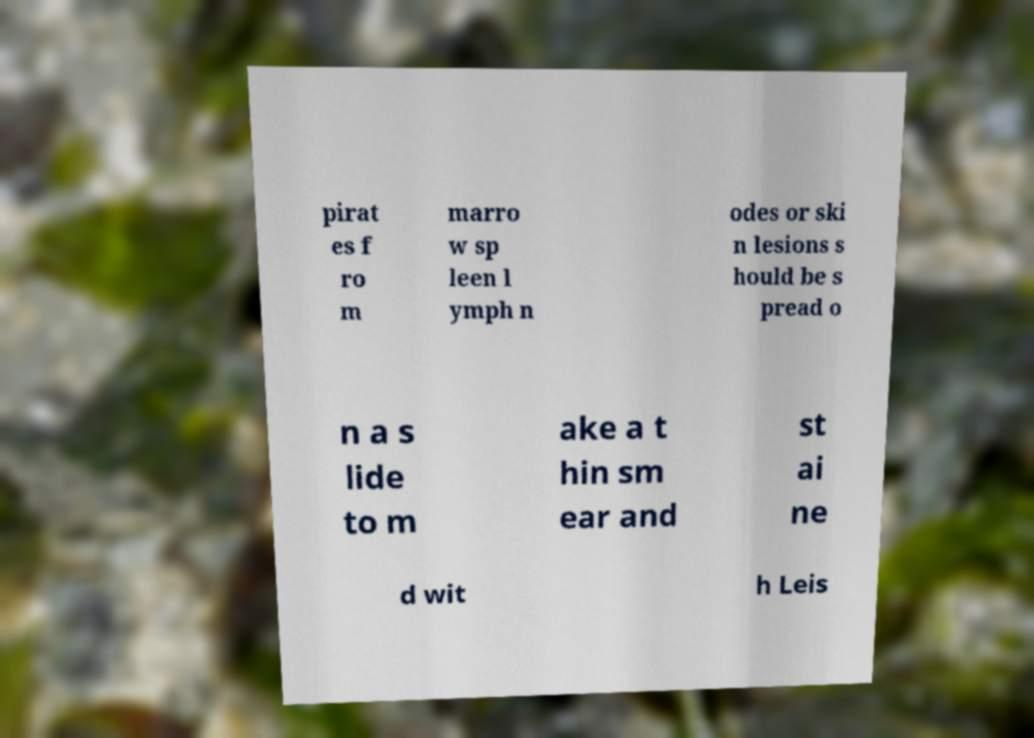What messages or text are displayed in this image? I need them in a readable, typed format. pirat es f ro m marro w sp leen l ymph n odes or ski n lesions s hould be s pread o n a s lide to m ake a t hin sm ear and st ai ne d wit h Leis 